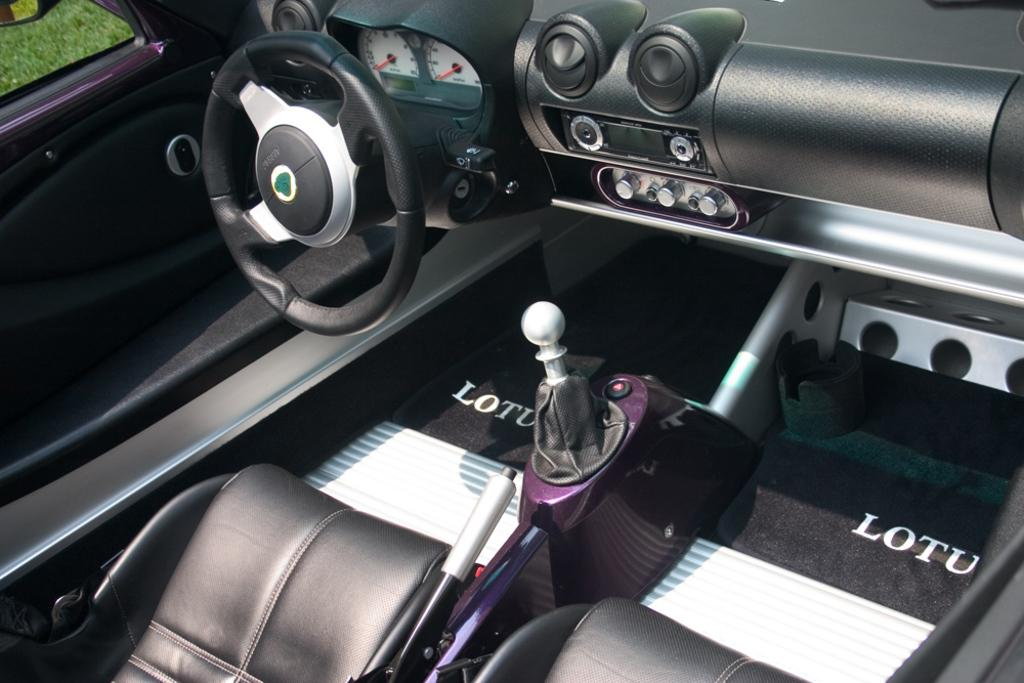What type of setting is depicted in the image? The image shows the interior of a vehicle. Can you describe any elements visible outside the vehicle? Yes, there is grass visible in the image. What is the income of the person sitting in the vehicle in the image? There is no information about the person's income in the image. Is there a fight happening inside the vehicle in the image? There is no indication of a fight or any conflict in the image. 